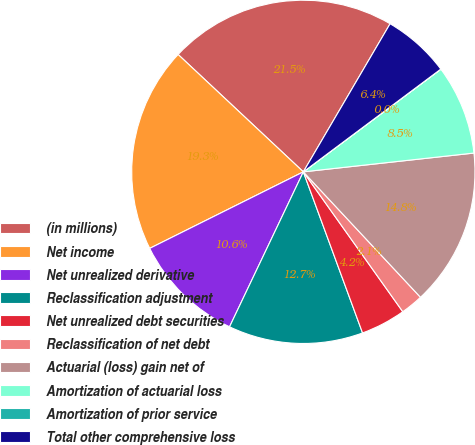<chart> <loc_0><loc_0><loc_500><loc_500><pie_chart><fcel>(in millions)<fcel>Net income<fcel>Net unrealized derivative<fcel>Reclassification adjustment<fcel>Net unrealized debt securities<fcel>Reclassification of net debt<fcel>Actuarial (loss) gain net of<fcel>Amortization of actuarial loss<fcel>Amortization of prior service<fcel>Total other comprehensive loss<nl><fcel>21.45%<fcel>19.34%<fcel>10.57%<fcel>12.68%<fcel>4.23%<fcel>2.12%<fcel>14.79%<fcel>8.46%<fcel>0.01%<fcel>6.35%<nl></chart> 